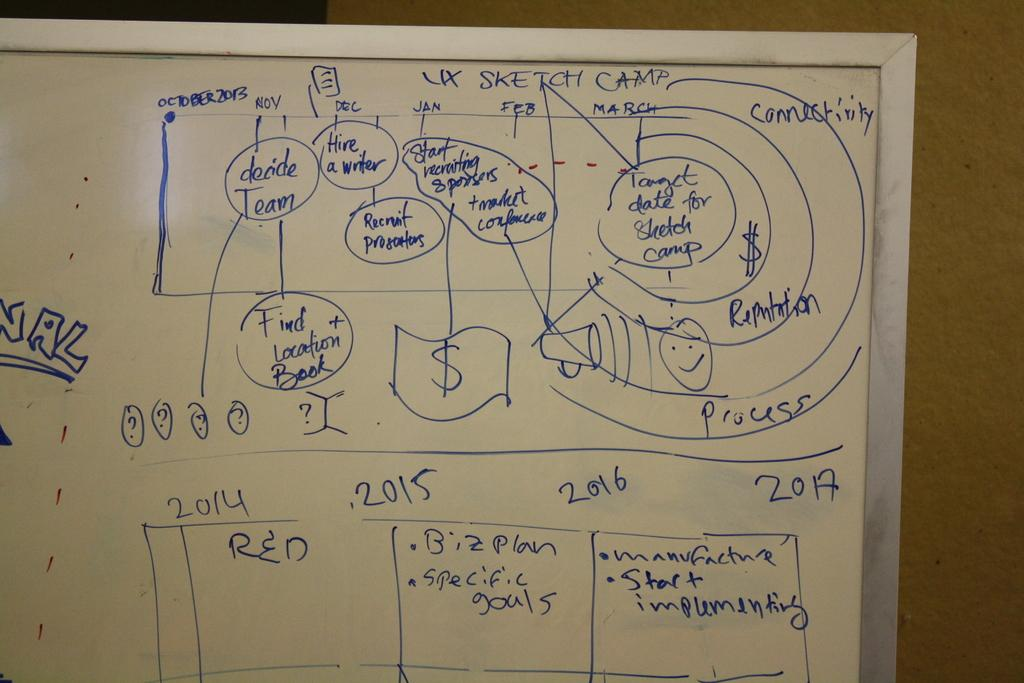<image>
Give a short and clear explanation of the subsequent image. A dry erase board with dates and "Sketch Camp" at the top is seen. 